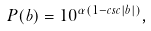Convert formula to latex. <formula><loc_0><loc_0><loc_500><loc_500>P ( b ) = 1 0 ^ { \alpha ( 1 - c s c | b | ) } ,</formula> 